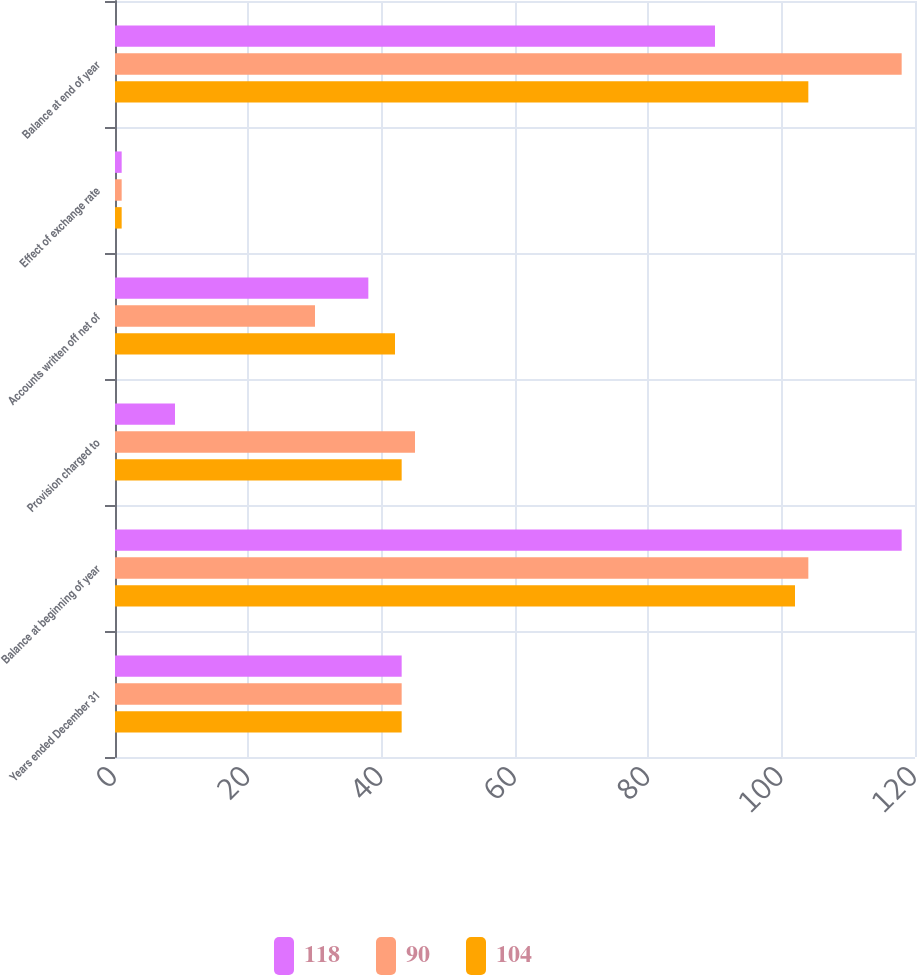Convert chart. <chart><loc_0><loc_0><loc_500><loc_500><stacked_bar_chart><ecel><fcel>Years ended December 31<fcel>Balance at beginning of year<fcel>Provision charged to<fcel>Accounts written off net of<fcel>Effect of exchange rate<fcel>Balance at end of year<nl><fcel>118<fcel>43<fcel>118<fcel>9<fcel>38<fcel>1<fcel>90<nl><fcel>90<fcel>43<fcel>104<fcel>45<fcel>30<fcel>1<fcel>118<nl><fcel>104<fcel>43<fcel>102<fcel>43<fcel>42<fcel>1<fcel>104<nl></chart> 